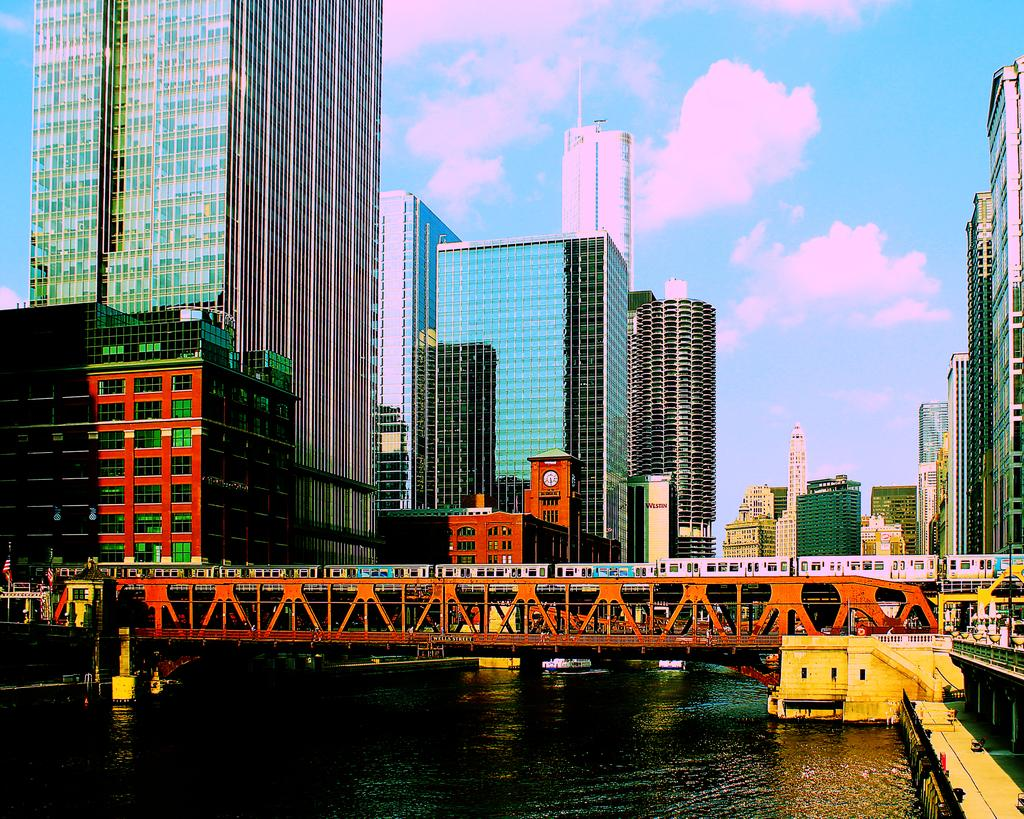What structure is present in the image that connects two areas? There is a bridge in the image that connects two areas. What body of water is located beneath the bridge? There is a lake under the bridge. What can be seen behind the bridge in the image? There are buildings behind the bridge. How would you describe the sky in the image? The sky is blue with clouds. What type of wall can be seen surrounding the lake in the image? There is no wall surrounding the lake in the image; it is open to the surrounding landscape. What process is being carried out by the horse in the image? There is no horse present in the image, so no process can be observed. 